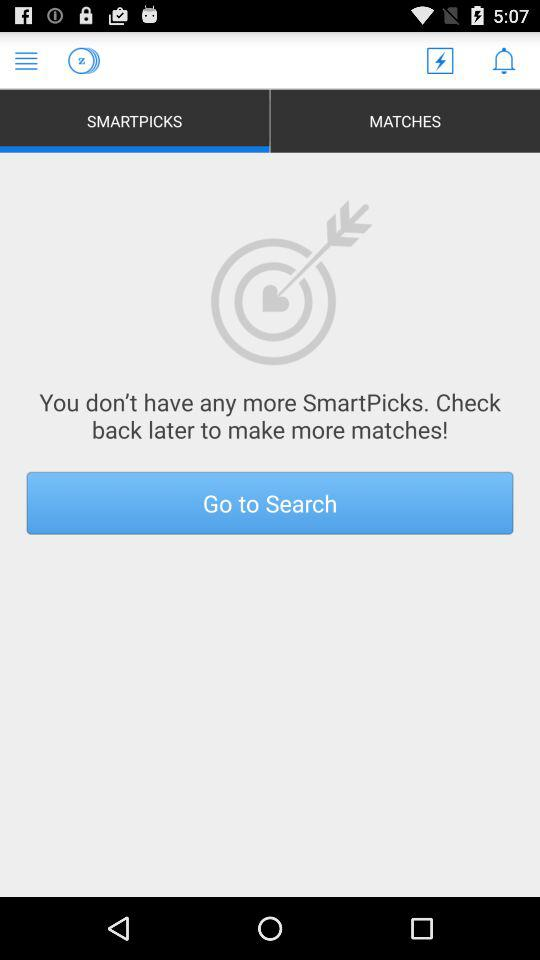Which tab am I using? You are using the "SMARTPICKS" tab. 